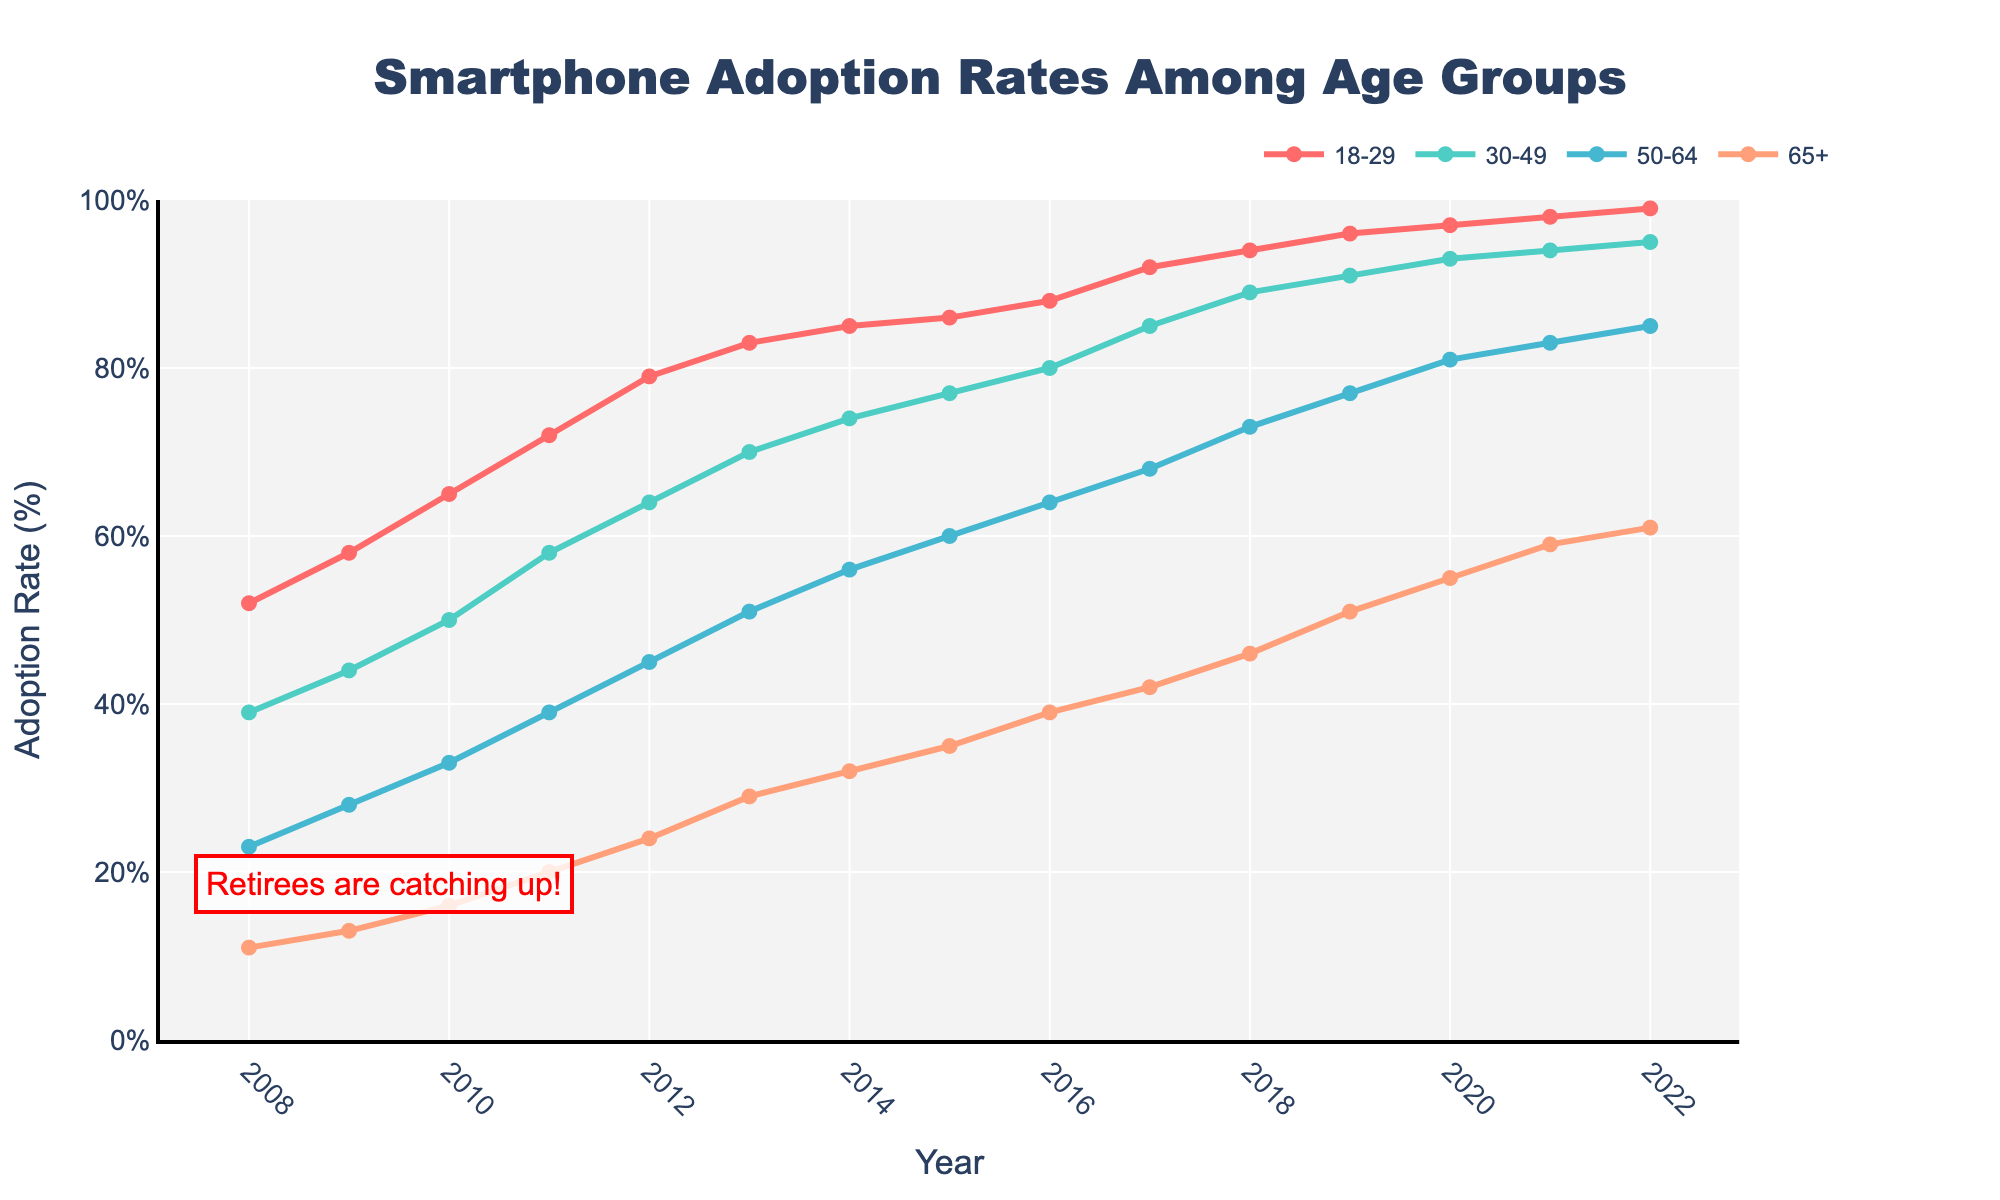How has the adoption rate of smartphones for the 65+ age group changed from 2008 to 2022? In 2008, the adoption rate for the 65+ age group was 11%. By 2022, it increased to 61%. The change is the difference between these two values, which is 61% - 11% = 50%.
Answer: The adoption rate increased by 50% Which age group had the highest smartphone adoption rate in 2010? By looking at the adoption rates for 2010, the 18-29 age group had the highest rate at 65%.
Answer: The 18-29 age group What is the difference in smartphone adoption rates between the 50-64 age group and the 65+ age group in 2015? In 2015, the adoption rates were 60% for the 50-64 age group and 35% for the 65+ age group. The difference is 60% - 35% = 25%.
Answer: 25% Which age group showed the greatest increase in smartphone adoption rate over the 15 years? To determine this, we need to see the increase in adoption rate from 2008 to 2022 for each age group. For the 18-29 age group, the increase is 99% - 52% = 47%. For the 30-49 age group, it is 95% - 39% = 56%. For the 50-64 age group, it is 85% - 23% = 62%. For the 65+ age group, it is 61% - 11% = 50%. So, the greatest increase is for the 50-64 age group with 62%.
Answer: The 50-64 age group In what year did the 30-49 age group surpass a 70% smartphone adoption rate? Referring to the chart, the 30-49 age group surpasses 70% in 2013 when the rate was 70%.
Answer: 2013 By how much did the smartphone adoption rate of the 50-64 age group exceed the 65+ age group in 2012? In 2012, the adoption rate for the 50-64 age group was 45% and for the 65+ age group, it was 24%. The difference is 45% - 24% = 21%.
Answer: 21% What general trend can be observed in smartphone adoption rates across all age groups from 2008 to 2022? All age groups show an increasing trend in smartphone adoption rates over the years from 2008 to 2022, with significant upward slopes.
Answer: Increasing trend for all age groups Comparing the year 2011, which age group has the least smartphone adoption rate, and what is it? In 2011, the 65+ age group had the least smartphone adoption rate at 20%.
Answer: The 65+ age group with 20% What is the average smartphone adoption rate for the 18-29 age group over the whole period? The average adoption rate is calculated by summing the rates for each year and dividing by the number of years. The sum from 2008 to 2022: 52+58+65+72+79+83+85+86+88+92+94+96+97+98+99=1239. There are 15 years, so the average is 1239/15 ≈ 82.6%.
Answer: Approximately 82.6% 